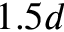Convert formula to latex. <formula><loc_0><loc_0><loc_500><loc_500>1 . 5 d</formula> 